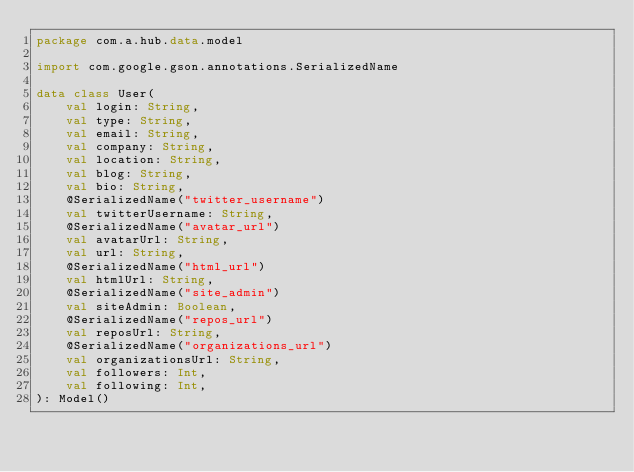<code> <loc_0><loc_0><loc_500><loc_500><_Kotlin_>package com.a.hub.data.model

import com.google.gson.annotations.SerializedName

data class User(
    val login: String,
    val type: String,
    val email: String,
    val company: String,
    val location: String,
    val blog: String,
    val bio: String,
    @SerializedName("twitter_username")
    val twitterUsername: String,
    @SerializedName("avatar_url")
    val avatarUrl: String,
    val url: String,
    @SerializedName("html_url")
    val htmlUrl: String,
    @SerializedName("site_admin")
    val siteAdmin: Boolean,
    @SerializedName("repos_url")
    val reposUrl: String,
    @SerializedName("organizations_url")
    val organizationsUrl: String,
    val followers: Int,
    val following: Int,
): Model()</code> 